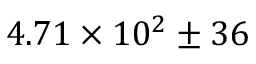Convert formula to latex. <formula><loc_0><loc_0><loc_500><loc_500>4 . 7 1 \times 1 0 ^ { 2 } \pm 3 6</formula> 